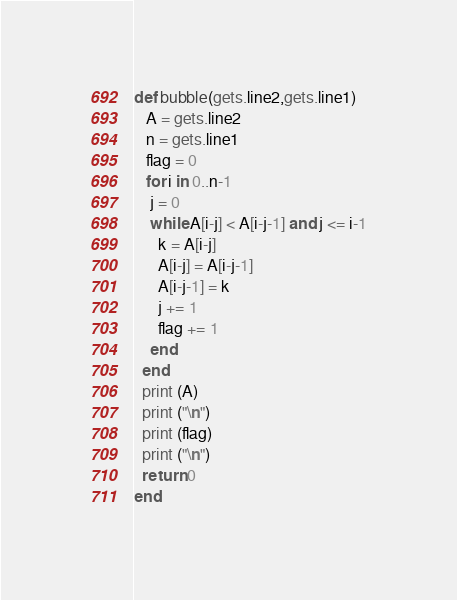Convert code to text. <code><loc_0><loc_0><loc_500><loc_500><_Ruby_>def bubble(gets.line2,gets.line1)
   A = gets.line2
   n = gets.line1
   flag = 0           
   for i in 0..n-1
    j = 0
    while A[i-j] < A[i-j-1] and j <= i-1
      k = A[i-j]
      A[i-j] = A[i-j-1]
      A[i-j-1] = k
      j += 1
      flag += 1
    end
  end
  print (A)
  print ("\n")
  print (flag)
  print ("\n")
  return 0
end
</code> 